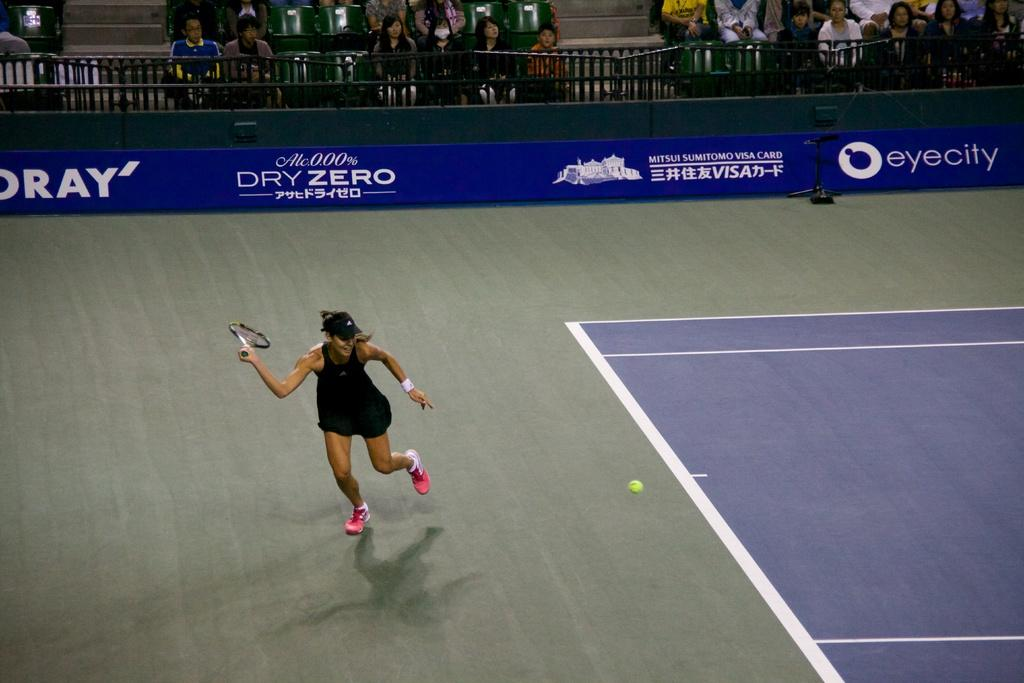Who is the main subject in the image? There is a woman in the image. What is the woman doing in the image? The woman is standing and holding a tennis racket in her hand. Can you describe the people in the background of the image? There are people in the background of the image, and they are watching the woman. What type of curtain can be seen in the image? There is no curtain present in the image. What type of business is being conducted in the image? There is no business being conducted in the image; it features a woman holding a tennis racket and people watching her. Can you describe the cactus in the image? There is no cactus present in the image. 